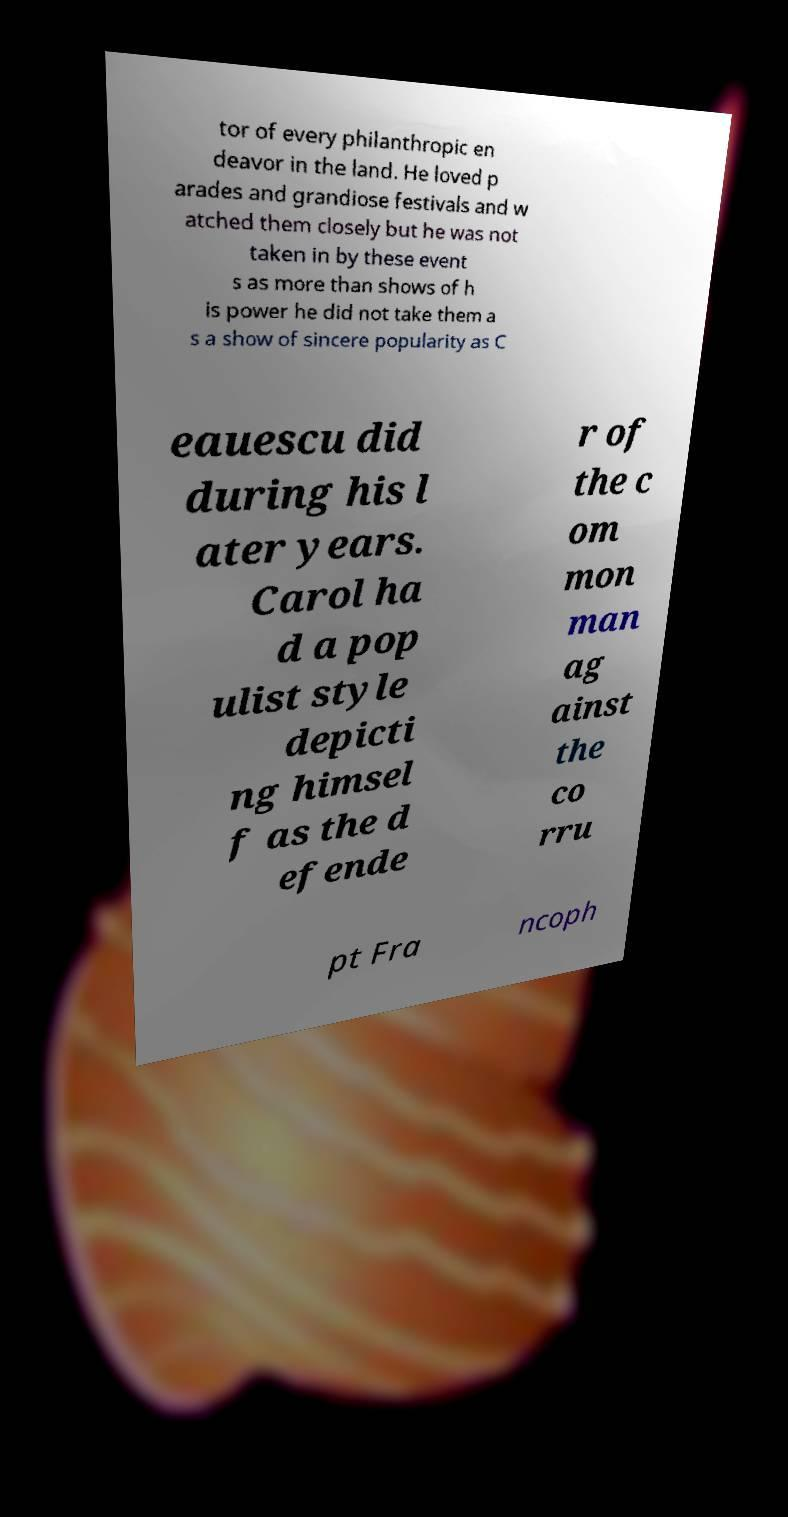Please read and relay the text visible in this image. What does it say? tor of every philanthropic en deavor in the land. He loved p arades and grandiose festivals and w atched them closely but he was not taken in by these event s as more than shows of h is power he did not take them a s a show of sincere popularity as C eauescu did during his l ater years. Carol ha d a pop ulist style depicti ng himsel f as the d efende r of the c om mon man ag ainst the co rru pt Fra ncoph 